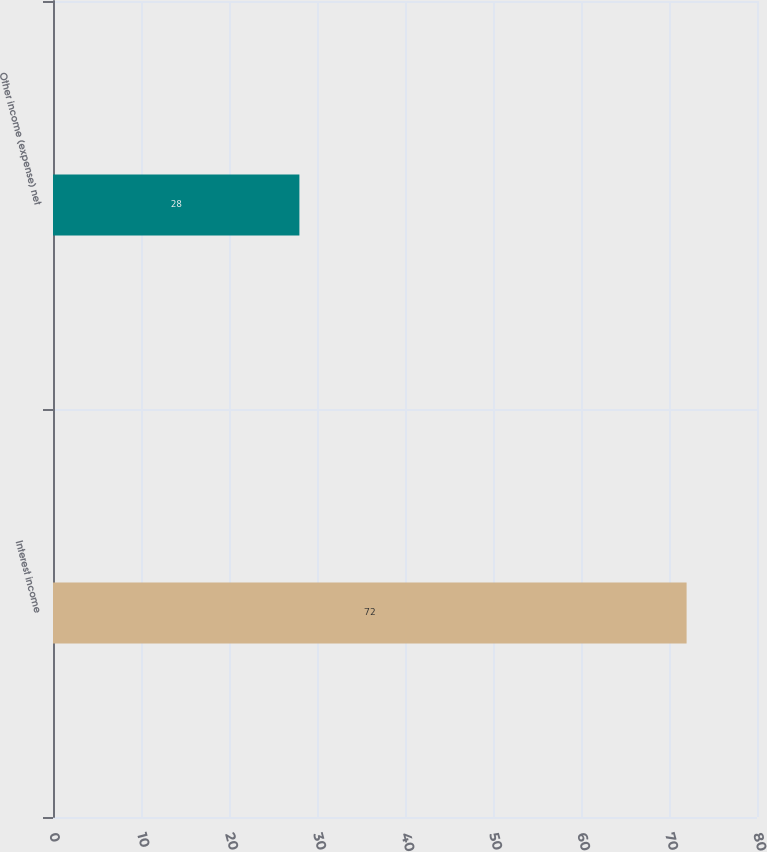<chart> <loc_0><loc_0><loc_500><loc_500><bar_chart><fcel>Interest income<fcel>Other income (expense) net<nl><fcel>72<fcel>28<nl></chart> 